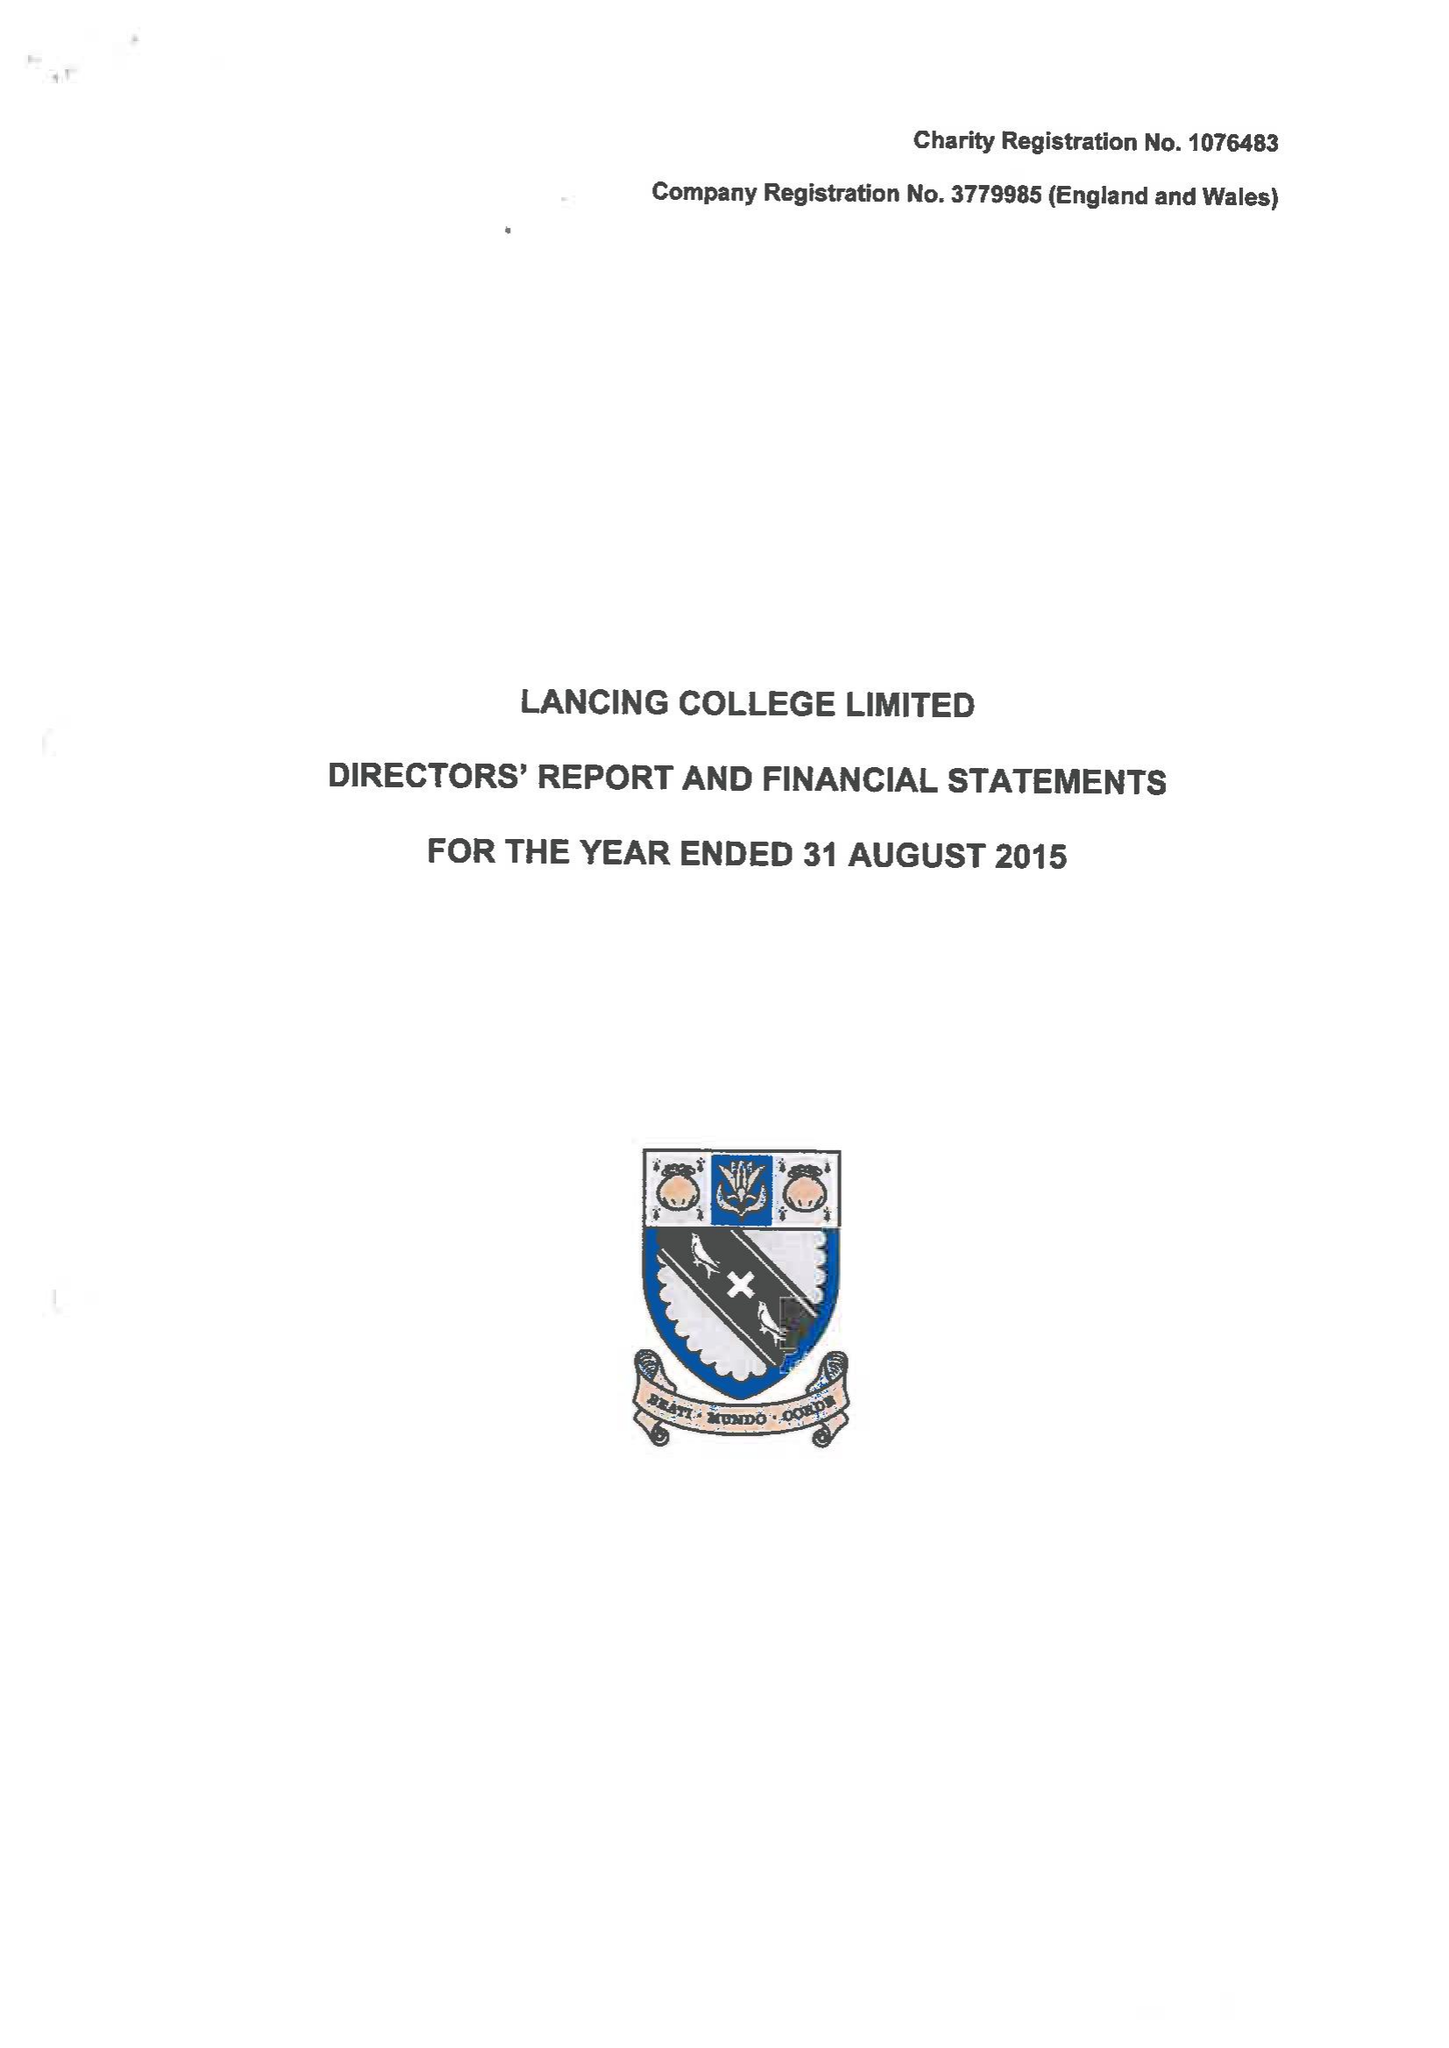What is the value for the income_annually_in_british_pounds?
Answer the question using a single word or phrase. 19379725.00 